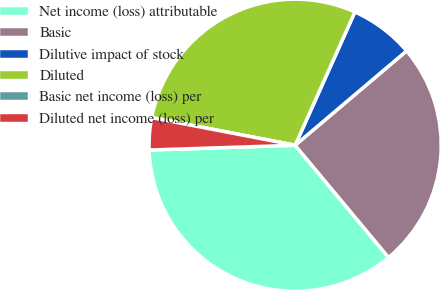<chart> <loc_0><loc_0><loc_500><loc_500><pie_chart><fcel>Net income (loss) attributable<fcel>Basic<fcel>Dilutive impact of stock<fcel>Diluted<fcel>Basic net income (loss) per<fcel>Diluted net income (loss) per<nl><fcel>35.53%<fcel>25.13%<fcel>7.11%<fcel>28.68%<fcel>0.0%<fcel>3.55%<nl></chart> 